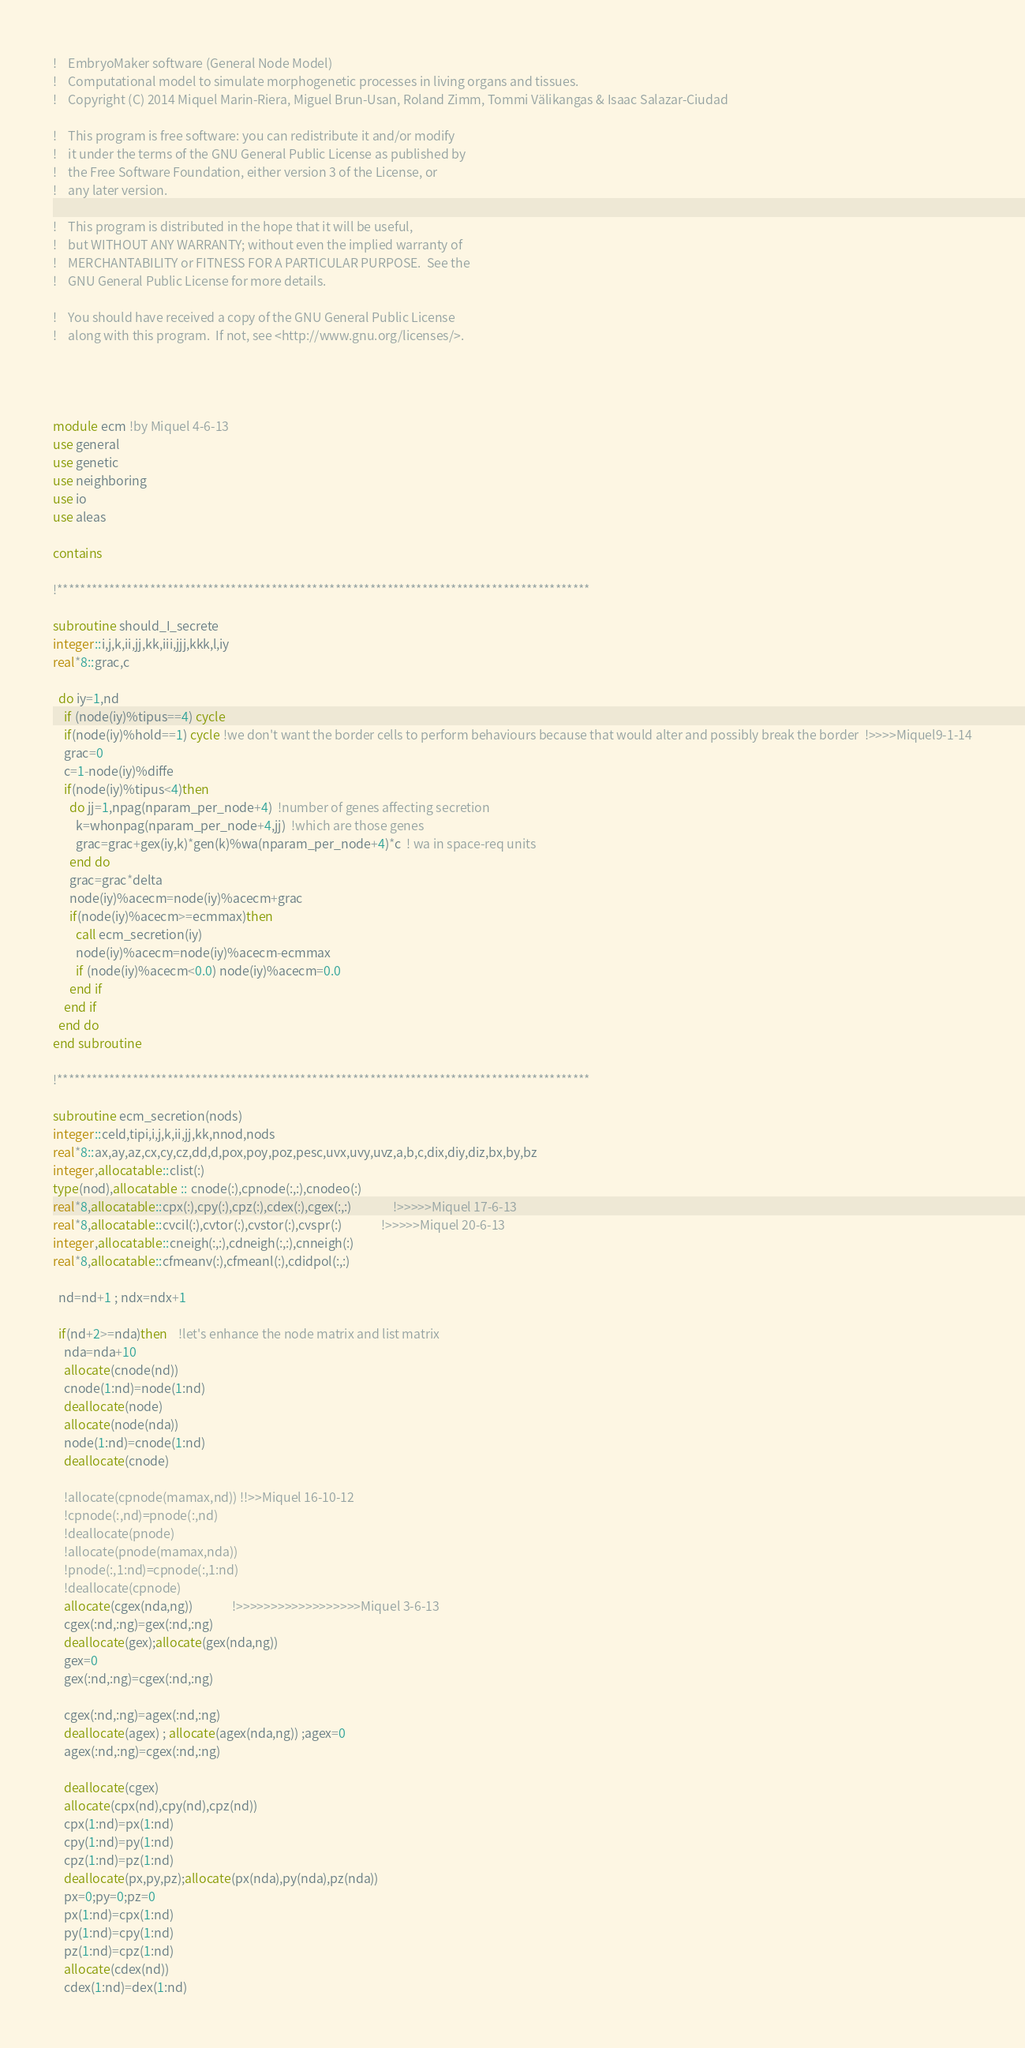<code> <loc_0><loc_0><loc_500><loc_500><_FORTRAN_>!    EmbryoMaker software (General Node Model)
!    Computational model to simulate morphogenetic processes in living organs and tissues.
!    Copyright (C) 2014 Miquel Marin-Riera, Miguel Brun-Usan, Roland Zimm, Tommi Välikangas & Isaac Salazar-Ciudad

!    This program is free software: you can redistribute it and/or modify
!    it under the terms of the GNU General Public License as published by
!    the Free Software Foundation, either version 3 of the License, or
!    any later version.

!    This program is distributed in the hope that it will be useful,
!    but WITHOUT ANY WARRANTY; without even the implied warranty of
!    MERCHANTABILITY or FITNESS FOR A PARTICULAR PURPOSE.  See the
!    GNU General Public License for more details.

!    You should have received a copy of the GNU General Public License
!    along with this program.  If not, see <http://www.gnu.org/licenses/>.




module ecm !by Miquel 4-6-13
use general
use genetic
use neighboring
use io
use aleas

contains

!********************************************************************************************

subroutine should_I_secrete
integer::i,j,k,ii,jj,kk,iii,jjj,kkk,l,iy
real*8::grac,c

  do iy=1,nd
    if (node(iy)%tipus==4) cycle
    if(node(iy)%hold==1) cycle !we don't want the border cells to perform behaviours because that would alter and possibly break the border  !>>>>Miquel9-1-14
    grac=0
    c=1-node(iy)%diffe
    if(node(iy)%tipus<4)then
      do jj=1,npag(nparam_per_node+4)  !number of genes affecting secretion
        k=whonpag(nparam_per_node+4,jj)  !which are those genes
        grac=grac+gex(iy,k)*gen(k)%wa(nparam_per_node+4)*c  ! wa in space-req units
      end do
      grac=grac*delta
      node(iy)%acecm=node(iy)%acecm+grac
      if(node(iy)%acecm>=ecmmax)then
        call ecm_secretion(iy)
        node(iy)%acecm=node(iy)%acecm-ecmmax
        if (node(iy)%acecm<0.0) node(iy)%acecm=0.0
      end if
    end if
  end do
end subroutine

!********************************************************************************************

subroutine ecm_secretion(nods)
integer::celd,tipi,i,j,k,ii,jj,kk,nnod,nods
real*8::ax,ay,az,cx,cy,cz,dd,d,pox,poy,poz,pesc,uvx,uvy,uvz,a,b,c,dix,diy,diz,bx,by,bz
integer,allocatable::clist(:)
type(nod),allocatable :: cnode(:),cpnode(:,:),cnodeo(:)
real*8,allocatable::cpx(:),cpy(:),cpz(:),cdex(:),cgex(:,:)               !>>>>>Miquel 17-6-13
real*8,allocatable::cvcil(:),cvtor(:),cvstor(:),cvspr(:)              !>>>>>Miquel 20-6-13
integer,allocatable::cneigh(:,:),cdneigh(:,:),cnneigh(:)
real*8,allocatable::cfmeanv(:),cfmeanl(:),cdidpol(:,:)

  nd=nd+1 ; ndx=ndx+1

  if(nd+2>=nda)then	!let's enhance the node matrix and list matrix
    nda=nda+10
    allocate(cnode(nd))
    cnode(1:nd)=node(1:nd)
    deallocate(node)
    allocate(node(nda))
    node(1:nd)=cnode(1:nd)  
    deallocate(cnode)

    !allocate(cpnode(mamax,nd))	!!>>Miquel 16-10-12
    !cpnode(:,nd)=pnode(:,nd)
    !deallocate(pnode)
    !allocate(pnode(mamax,nda))
    !pnode(:,1:nd)=cpnode(:,1:nd)
    !deallocate(cpnode)
    allocate(cgex(nda,ng))              !>>>>>>>>>>>>>>>>>>Miquel 3-6-13
    cgex(:nd,:ng)=gex(:nd,:ng)
    deallocate(gex);allocate(gex(nda,ng))
    gex=0
    gex(:nd,:ng)=cgex(:nd,:ng)
    
    cgex(:nd,:ng)=agex(:nd,:ng)
    deallocate(agex) ; allocate(agex(nda,ng)) ;agex=0
    agex(:nd,:ng)=cgex(:nd,:ng)

    deallocate(cgex)
    allocate(cpx(nd),cpy(nd),cpz(nd))
    cpx(1:nd)=px(1:nd)
    cpy(1:nd)=py(1:nd)
    cpz(1:nd)=pz(1:nd)
    deallocate(px,py,pz);allocate(px(nda),py(nda),pz(nda))
    px=0;py=0;pz=0
    px(1:nd)=cpx(1:nd)
    py(1:nd)=cpy(1:nd)
    pz(1:nd)=cpz(1:nd)
    allocate(cdex(nd))
    cdex(1:nd)=dex(1:nd)</code> 